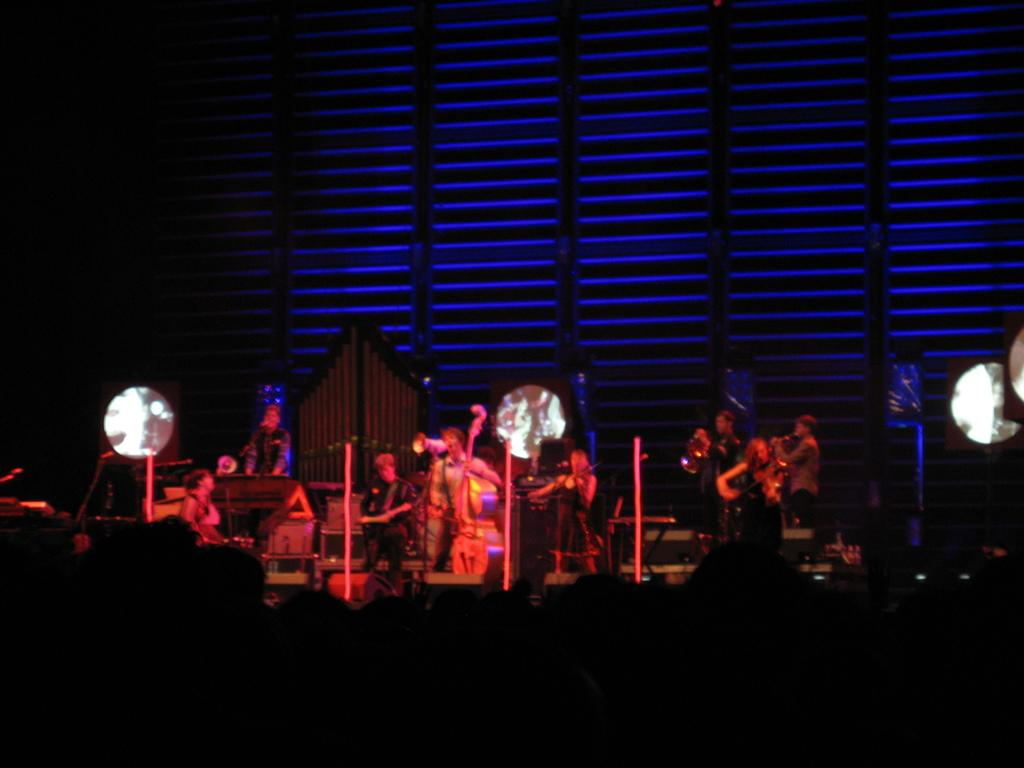What is happening in the image? There is a group of people in the image. Where are the people located? The people are standing on a stage. What are the people doing on the stage? The people are holding musical instruments. What can be seen behind the people on the stage? There is a dark background in the image. What type of event is causing the people to exchange feelings of anger on the stage? There is no event or exchange of anger depicted in the image; the people are simply holding musical instruments on a stage. 